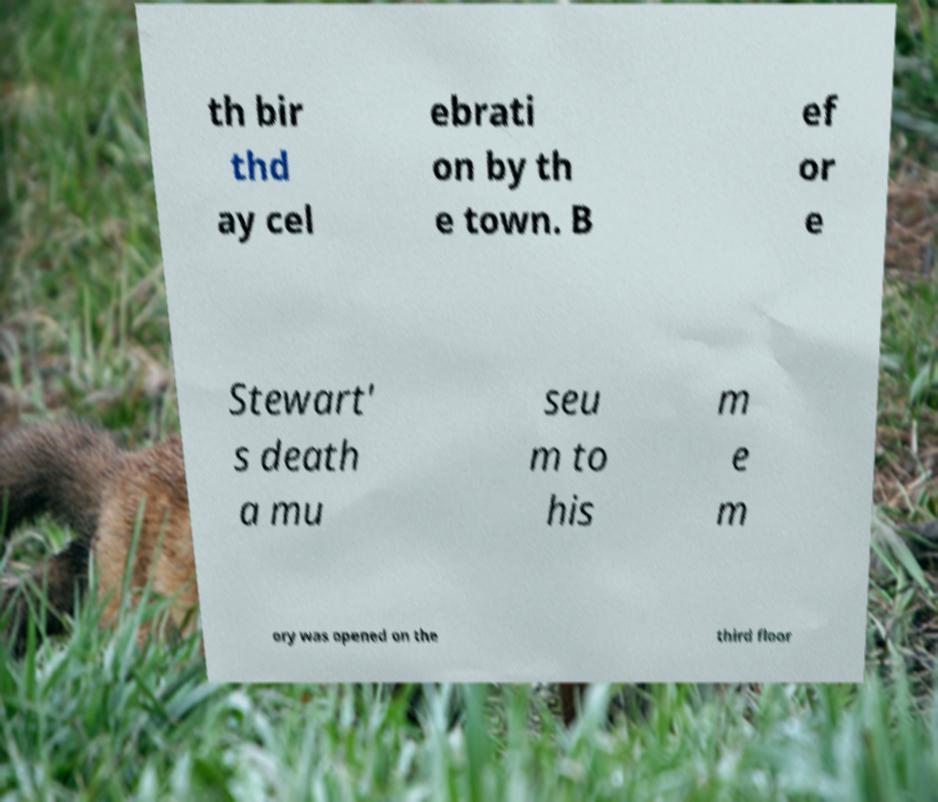For documentation purposes, I need the text within this image transcribed. Could you provide that? th bir thd ay cel ebrati on by th e town. B ef or e Stewart' s death a mu seu m to his m e m ory was opened on the third floor 